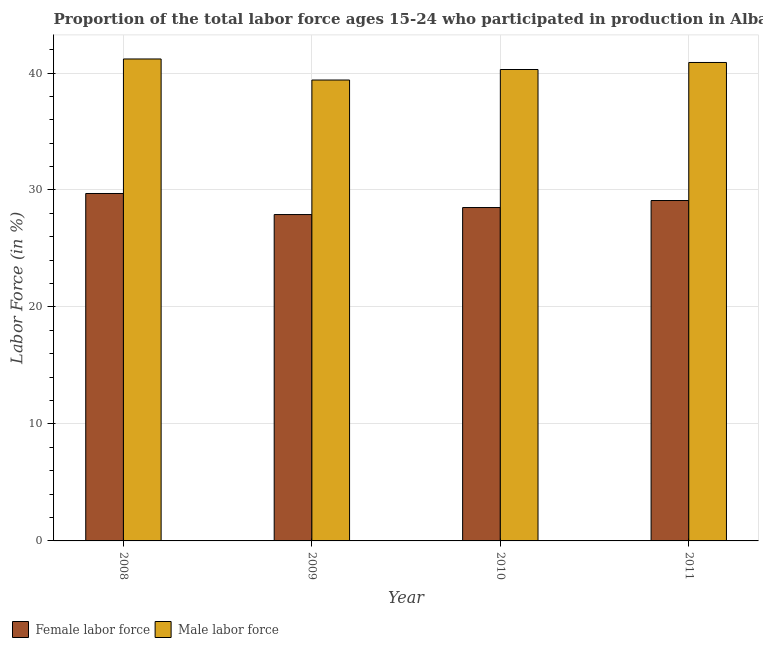How many different coloured bars are there?
Offer a very short reply. 2. Are the number of bars on each tick of the X-axis equal?
Your response must be concise. Yes. What is the percentage of female labor force in 2011?
Your answer should be compact. 29.1. Across all years, what is the maximum percentage of female labor force?
Offer a terse response. 29.7. Across all years, what is the minimum percentage of female labor force?
Give a very brief answer. 27.9. In which year was the percentage of male labour force maximum?
Your answer should be compact. 2008. What is the total percentage of female labor force in the graph?
Make the answer very short. 115.2. What is the difference between the percentage of male labour force in 2008 and the percentage of female labor force in 2009?
Offer a terse response. 1.8. What is the average percentage of female labor force per year?
Make the answer very short. 28.8. In how many years, is the percentage of male labour force greater than 18 %?
Keep it short and to the point. 4. What is the ratio of the percentage of female labor force in 2008 to that in 2009?
Ensure brevity in your answer.  1.06. Is the difference between the percentage of female labor force in 2010 and 2011 greater than the difference between the percentage of male labour force in 2010 and 2011?
Make the answer very short. No. What is the difference between the highest and the second highest percentage of female labor force?
Give a very brief answer. 0.6. What is the difference between the highest and the lowest percentage of male labour force?
Make the answer very short. 1.8. In how many years, is the percentage of female labor force greater than the average percentage of female labor force taken over all years?
Keep it short and to the point. 2. What does the 2nd bar from the left in 2009 represents?
Provide a succinct answer. Male labor force. What does the 2nd bar from the right in 2009 represents?
Your answer should be compact. Female labor force. How many bars are there?
Provide a short and direct response. 8. Are all the bars in the graph horizontal?
Make the answer very short. No. What is the difference between two consecutive major ticks on the Y-axis?
Give a very brief answer. 10. How many legend labels are there?
Provide a short and direct response. 2. What is the title of the graph?
Ensure brevity in your answer.  Proportion of the total labor force ages 15-24 who participated in production in Albania. Does "Taxes on profits and capital gains" appear as one of the legend labels in the graph?
Ensure brevity in your answer.  No. What is the label or title of the Y-axis?
Provide a short and direct response. Labor Force (in %). What is the Labor Force (in %) of Female labor force in 2008?
Give a very brief answer. 29.7. What is the Labor Force (in %) of Male labor force in 2008?
Your response must be concise. 41.2. What is the Labor Force (in %) of Female labor force in 2009?
Ensure brevity in your answer.  27.9. What is the Labor Force (in %) in Male labor force in 2009?
Make the answer very short. 39.4. What is the Labor Force (in %) of Female labor force in 2010?
Offer a very short reply. 28.5. What is the Labor Force (in %) of Male labor force in 2010?
Give a very brief answer. 40.3. What is the Labor Force (in %) in Female labor force in 2011?
Provide a succinct answer. 29.1. What is the Labor Force (in %) of Male labor force in 2011?
Provide a short and direct response. 40.9. Across all years, what is the maximum Labor Force (in %) in Female labor force?
Your response must be concise. 29.7. Across all years, what is the maximum Labor Force (in %) in Male labor force?
Provide a short and direct response. 41.2. Across all years, what is the minimum Labor Force (in %) of Female labor force?
Offer a very short reply. 27.9. Across all years, what is the minimum Labor Force (in %) of Male labor force?
Give a very brief answer. 39.4. What is the total Labor Force (in %) in Female labor force in the graph?
Provide a short and direct response. 115.2. What is the total Labor Force (in %) in Male labor force in the graph?
Make the answer very short. 161.8. What is the difference between the Labor Force (in %) of Female labor force in 2008 and that in 2009?
Ensure brevity in your answer.  1.8. What is the difference between the Labor Force (in %) in Female labor force in 2008 and that in 2010?
Offer a terse response. 1.2. What is the difference between the Labor Force (in %) of Male labor force in 2008 and that in 2011?
Provide a succinct answer. 0.3. What is the difference between the Labor Force (in %) in Female labor force in 2009 and that in 2010?
Provide a succinct answer. -0.6. What is the difference between the Labor Force (in %) in Male labor force in 2009 and that in 2010?
Offer a terse response. -0.9. What is the difference between the Labor Force (in %) of Female labor force in 2009 and that in 2011?
Your answer should be compact. -1.2. What is the difference between the Labor Force (in %) of Male labor force in 2009 and that in 2011?
Your answer should be very brief. -1.5. What is the difference between the Labor Force (in %) in Female labor force in 2008 and the Labor Force (in %) in Male labor force in 2010?
Your answer should be compact. -10.6. What is the difference between the Labor Force (in %) in Female labor force in 2009 and the Labor Force (in %) in Male labor force in 2010?
Offer a terse response. -12.4. What is the average Labor Force (in %) of Female labor force per year?
Give a very brief answer. 28.8. What is the average Labor Force (in %) in Male labor force per year?
Ensure brevity in your answer.  40.45. In the year 2010, what is the difference between the Labor Force (in %) of Female labor force and Labor Force (in %) of Male labor force?
Provide a short and direct response. -11.8. What is the ratio of the Labor Force (in %) of Female labor force in 2008 to that in 2009?
Make the answer very short. 1.06. What is the ratio of the Labor Force (in %) in Male labor force in 2008 to that in 2009?
Make the answer very short. 1.05. What is the ratio of the Labor Force (in %) of Female labor force in 2008 to that in 2010?
Offer a very short reply. 1.04. What is the ratio of the Labor Force (in %) of Male labor force in 2008 to that in 2010?
Your answer should be compact. 1.02. What is the ratio of the Labor Force (in %) of Female labor force in 2008 to that in 2011?
Make the answer very short. 1.02. What is the ratio of the Labor Force (in %) of Male labor force in 2008 to that in 2011?
Your answer should be very brief. 1.01. What is the ratio of the Labor Force (in %) in Female labor force in 2009 to that in 2010?
Your response must be concise. 0.98. What is the ratio of the Labor Force (in %) of Male labor force in 2009 to that in 2010?
Offer a very short reply. 0.98. What is the ratio of the Labor Force (in %) of Female labor force in 2009 to that in 2011?
Your answer should be compact. 0.96. What is the ratio of the Labor Force (in %) in Male labor force in 2009 to that in 2011?
Ensure brevity in your answer.  0.96. What is the ratio of the Labor Force (in %) of Female labor force in 2010 to that in 2011?
Offer a very short reply. 0.98. What is the ratio of the Labor Force (in %) in Male labor force in 2010 to that in 2011?
Offer a very short reply. 0.99. What is the difference between the highest and the second highest Labor Force (in %) of Male labor force?
Offer a very short reply. 0.3. What is the difference between the highest and the lowest Labor Force (in %) of Female labor force?
Ensure brevity in your answer.  1.8. 